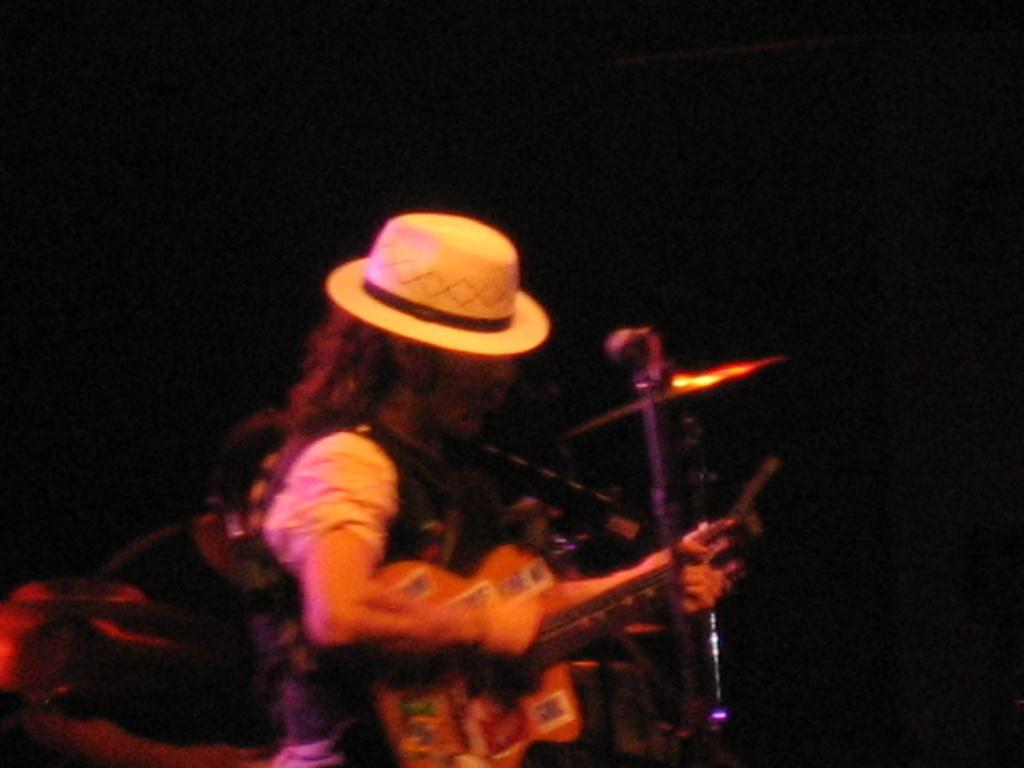Who is the main subject in the image? There is a man in the image. What is the man doing in the image? The man is playing a guitar. What object is the man positioned in front of? The man is in front of a microphone. What can be observed about the background of the image? The background of the image is dark. How does the man use his mouth to make a selection in the image? The man does not use his mouth to make a selection in the image; he is playing a guitar and standing in front of a microphone. 